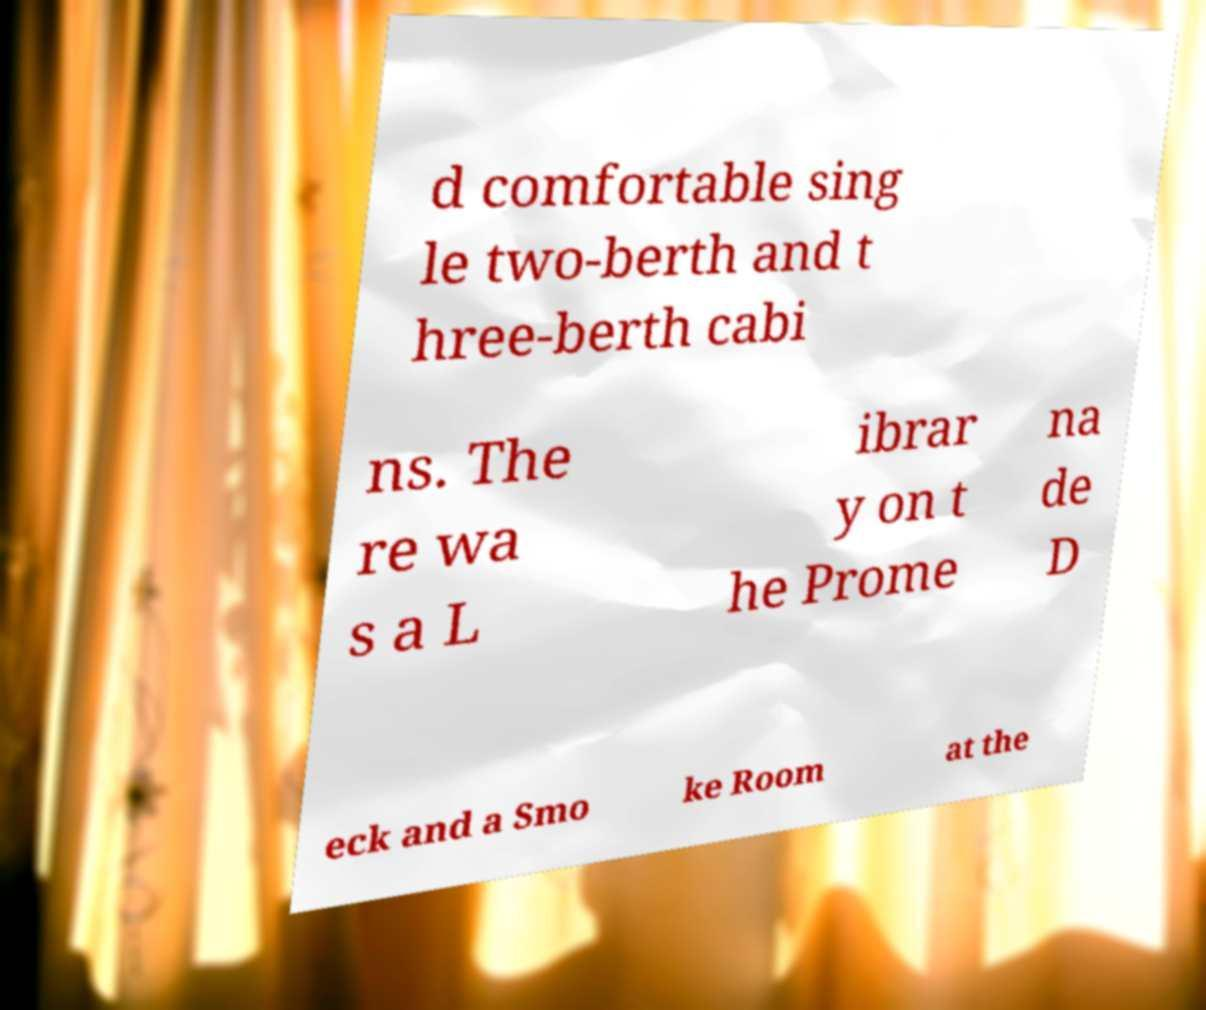I need the written content from this picture converted into text. Can you do that? d comfortable sing le two-berth and t hree-berth cabi ns. The re wa s a L ibrar y on t he Prome na de D eck and a Smo ke Room at the 